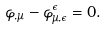Convert formula to latex. <formula><loc_0><loc_0><loc_500><loc_500>\varphi _ { , \mu } - \varphi _ { \mu , \epsilon } ^ { \epsilon } = 0 .</formula> 